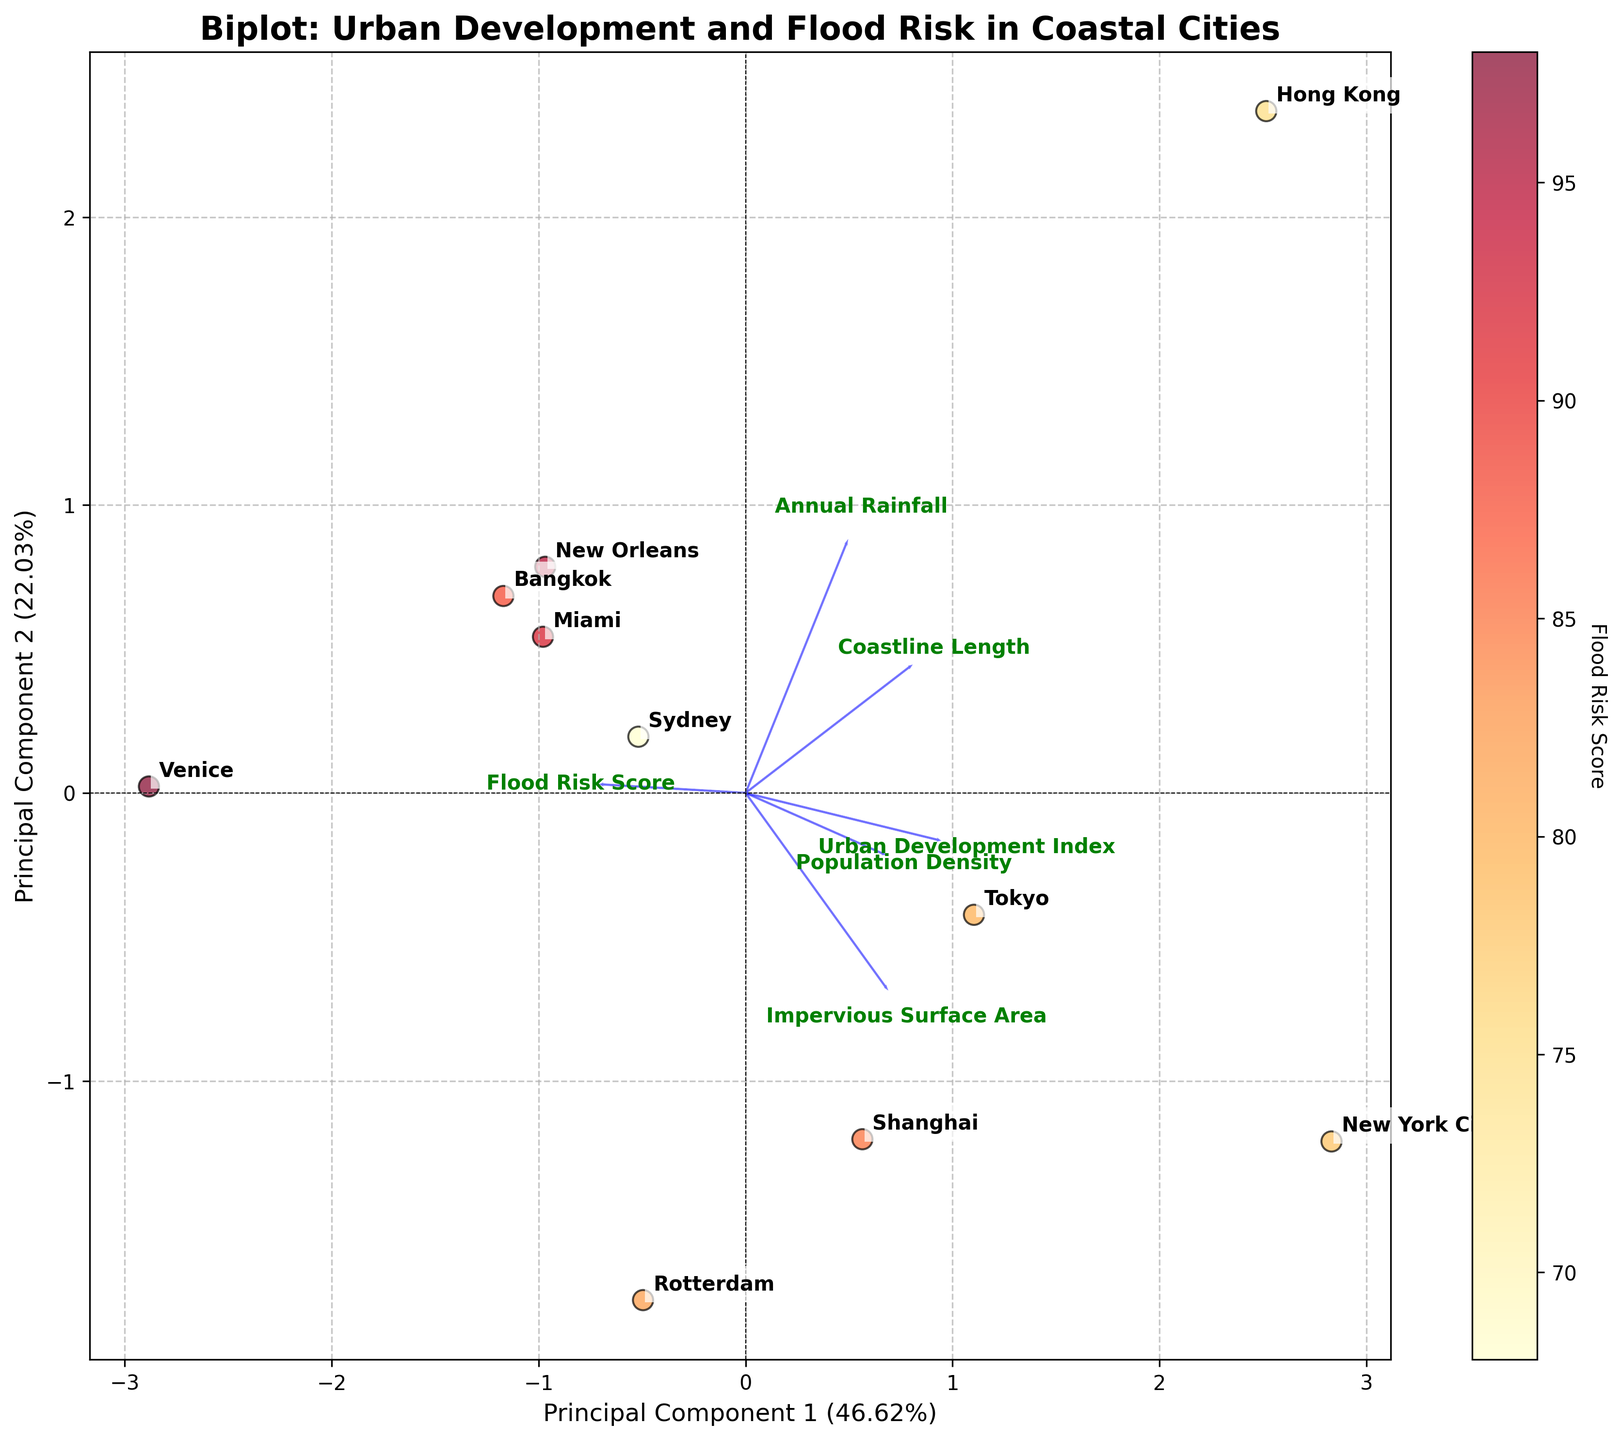How many principal components are plotted in the biplot? The figure axes are labeled "Principal Component 1" and "Principal Component 2," indicating that two principal components are plotted.
Answer: 2 What is the title of the biplot? The title of the figure is prominently displayed at the top and reads "Biplot: Urban Development and Flood Risk in Coastal Cities."
Answer: Biplot: Urban Development and Flood Risk in Coastal Cities Which principal component explains more variance in the data? The x-axis is labeled "Principal Component 1," and it includes the percentage (in parentheses) explaining more variance than the y-axis labeled "Principal Component 2." From the labels, Principal Component 1 explains more variance.
Answer: Principal Component 1 Which city has the highest flood risk score? The color intensity of the city's marker indicates the flood risk score, with darker colors representing higher scores. By examining the color bar and matching the darkest marker, "Venice" has the highest flood risk score.
Answer: Venice Which features have the most influence on Principal Component 1? The loadings arrows indicate the influence of each feature on the principal components. The longest arrows pointing in the same direction as Principal Component 1 have the most influence. "Urban Development Index" and "Impervious Surface Area" point most directly along the x-axis.
Answer: Urban Development Index and Impervious Surface Area Which city has the highest Urban Development Index? By referring to the positions of the cities along the direction of the "Urban Development Index" arrow, the city furthest in that direction is "Tokyo."
Answer: Tokyo How does annual rainfall correlate with flood risk score among the plotted cities? The direction and length of the "Annual Rainfall" arrow relative to the flood risk score indicators (color gradient) show this correlation. The arrow points roughly in the same direction as higher flood risk scores (darker colors), indicating a likely positive correlation.
Answer: Positive correlation Which city has the lowest population density? By looking at the position along the "Population Density" arrow, the city closest to the origin or in the opposite direction has the lowest density. "Venice" appears to be closest to the origin in that regard.
Answer: Venice Is there any city with both a high Urban Development Index and a high flood risk score? By observing the position of cities along both the "Urban Development Index" and flood risk score color gradient, we identify "Tokyo" and "New York City" as having high values in both categories due to their placement along the arrows and darker color indicators.
Answer: Tokyo and New York City Which feature contributes the least to Principal Component 2? Arrows representing features with the least contribution to Principal Component 2 are those with the shortest projections on the y-axis. "Coastline Length" has the least vertical projection, showing minimal contribution to PC2.
Answer: Coastline Length 